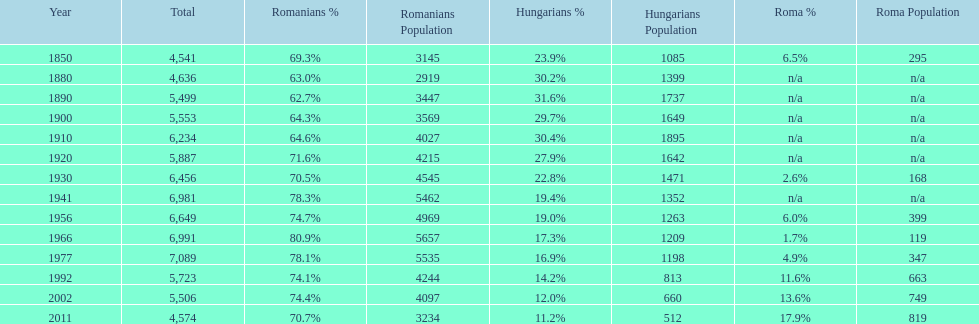What is the number of times the total population was 6,000 or more? 6. 